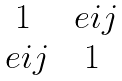<formula> <loc_0><loc_0><loc_500><loc_500>\begin{matrix} 1 & \ e { i } { j } \\ \ e { i } { j } & 1 \end{matrix}</formula> 